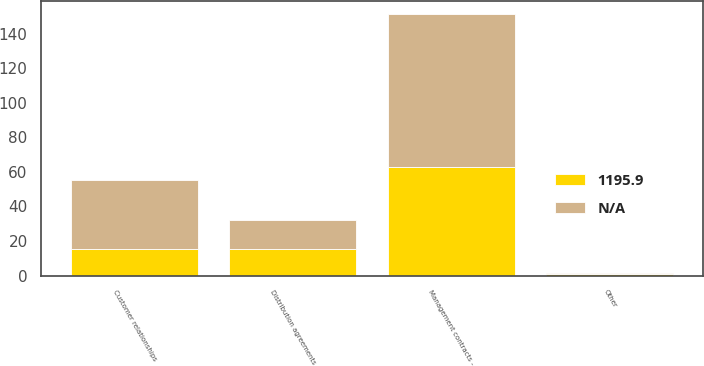<chart> <loc_0><loc_0><loc_500><loc_500><stacked_bar_chart><ecel><fcel>Management contracts -<fcel>Customer relationships<fcel>Other<fcel>Distribution agreements<nl><fcel>nan<fcel>88.8<fcel>40<fcel>0.8<fcel>17<nl><fcel>1195.9<fcel>62.9<fcel>15.2<fcel>0.7<fcel>15.2<nl></chart> 